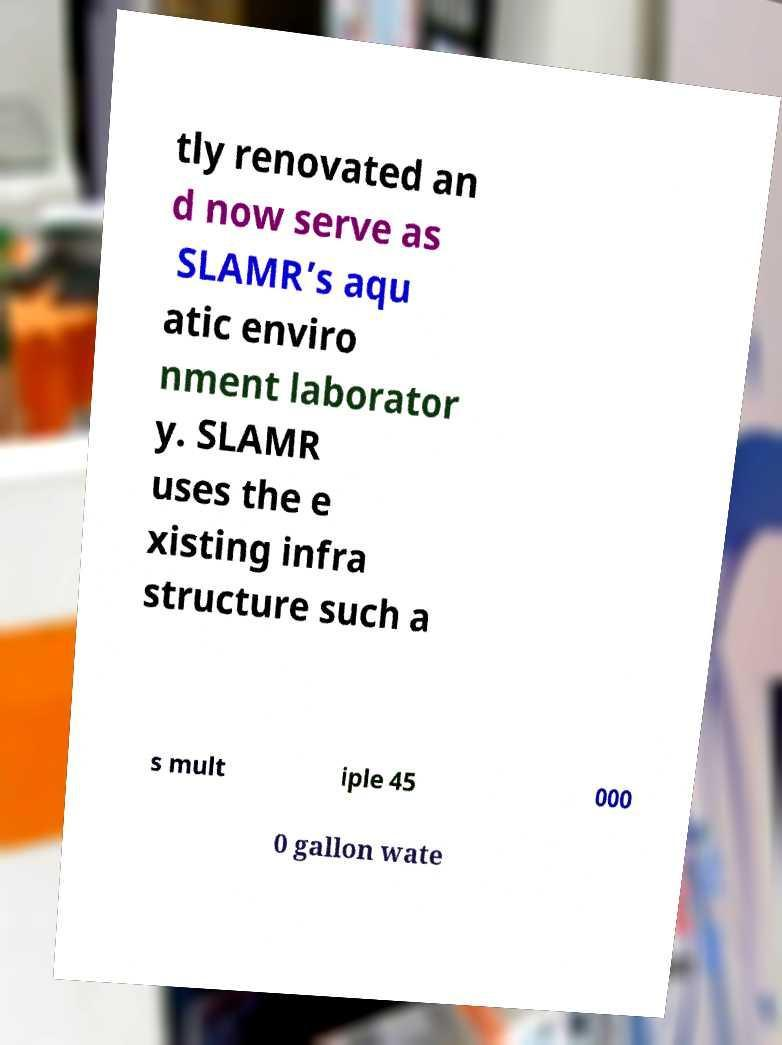Please identify and transcribe the text found in this image. tly renovated an d now serve as SLAMR’s aqu atic enviro nment laborator y. SLAMR uses the e xisting infra structure such a s mult iple 45 000 0 gallon wate 